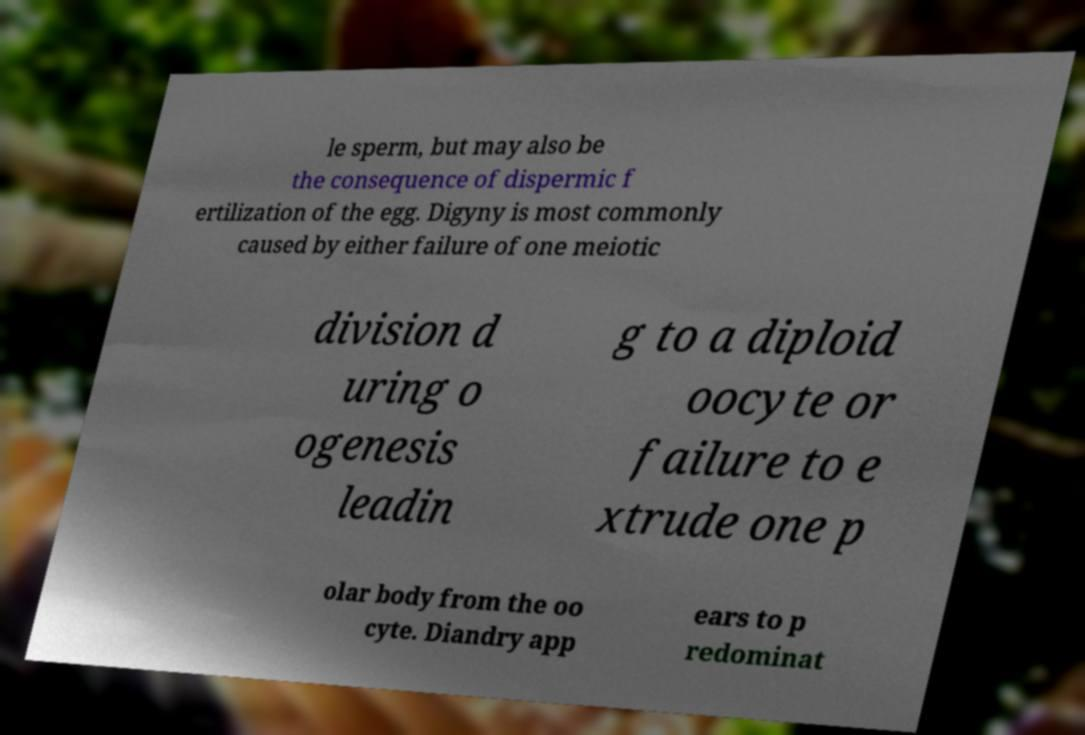Please read and relay the text visible in this image. What does it say? le sperm, but may also be the consequence of dispermic f ertilization of the egg. Digyny is most commonly caused by either failure of one meiotic division d uring o ogenesis leadin g to a diploid oocyte or failure to e xtrude one p olar body from the oo cyte. Diandry app ears to p redominat 